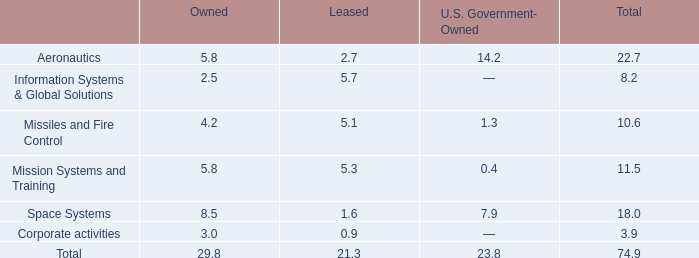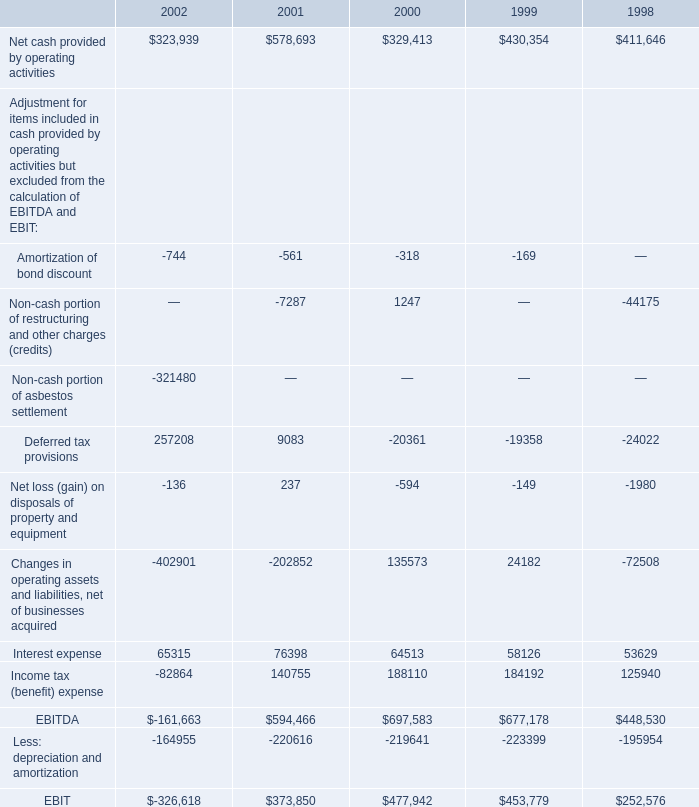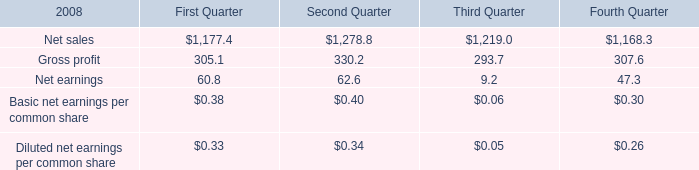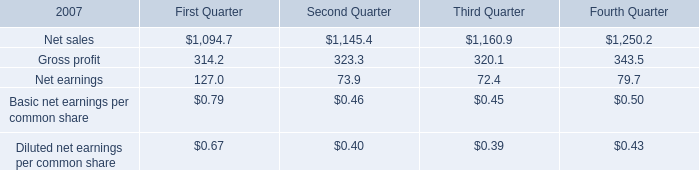What's the average of Net cash provided by operating activities of 1998, and Net sales of Second Quarter ? 
Computations: ((411646.0 + 1145.4) / 2)
Answer: 206395.7. 